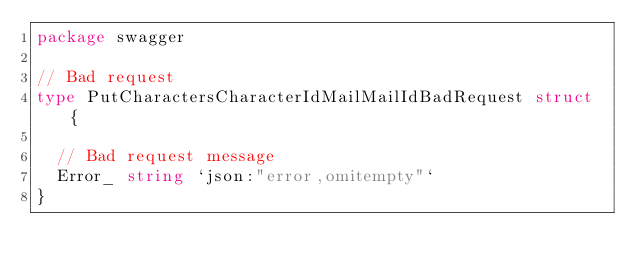<code> <loc_0><loc_0><loc_500><loc_500><_Go_>package swagger

// Bad request
type PutCharactersCharacterIdMailMailIdBadRequest struct {

	// Bad request message
	Error_ string `json:"error,omitempty"`
}
</code> 